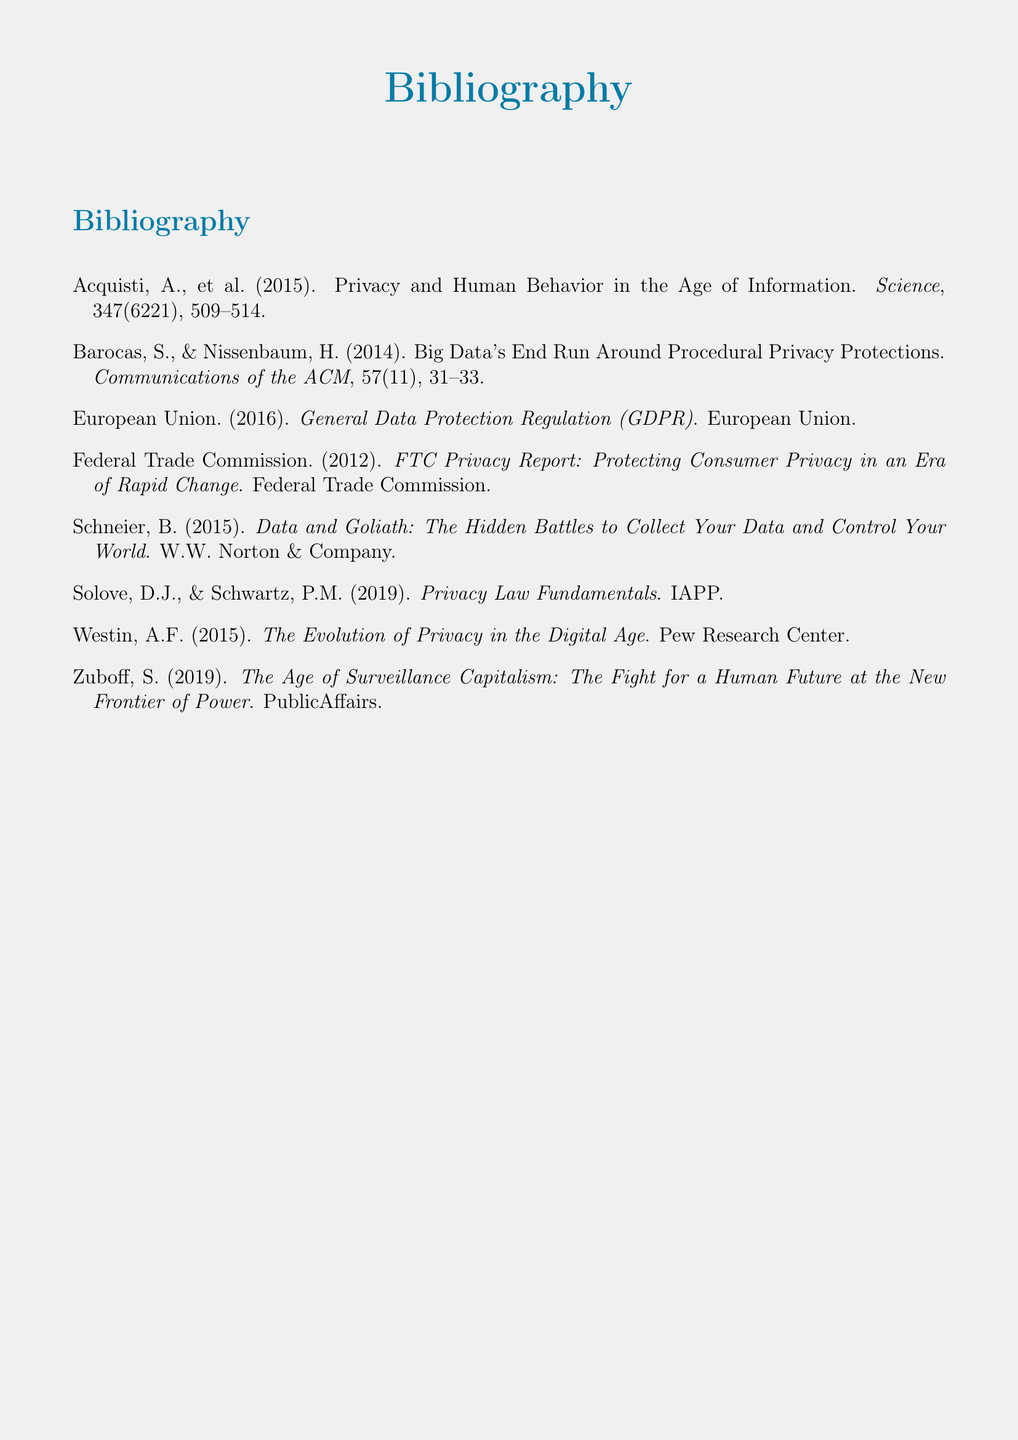What is the title of the first cited work? The title of the first cited work is the first part of the citation for Acquisti et al. (2015).
Answer: Privacy and Human Behavior in the Age of Information Who are the authors of the work discussing Big Data? The authors of the work discussing Big Data are listed in the citation for Baracas and Nissenbaum (2014).
Answer: Baracas, S., & Nissenbaum, H What year was the GDPR published? The publication year is found in the citation for the European Union (2016) entry.
Answer: 2016 How many sources are included in the bibliography? The number of sources is determined by counting the individual entries in the bibliography.
Answer: 8 What is the name of the publisher for the work by Schneier? The publisher can be found in the citation for Schneier (2015).
Answer: W.W. Norton & Company What is the subject of Westin's work? The subject is specified in the title of Westin's cited work.
Answer: The Evolution of Privacy in the Digital Age Which regulatory body issued a privacy report in 2012? The regulatory body is identified in the citation for the Federal Trade Commission (2012).
Answer: Federal Trade Commission What is the title of Zuboff's work? The title is clear from the citation for Zuboff (2019).
Answer: The Age of Surveillance Capitalism: The Fight for a Human Future at the New Frontier of Power 